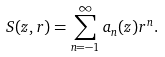Convert formula to latex. <formula><loc_0><loc_0><loc_500><loc_500>S ( z , r ) = \sum _ { n = - 1 } ^ { \infty } a _ { n } ( z ) r ^ { n } .</formula> 